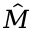<formula> <loc_0><loc_0><loc_500><loc_500>\hat { M }</formula> 